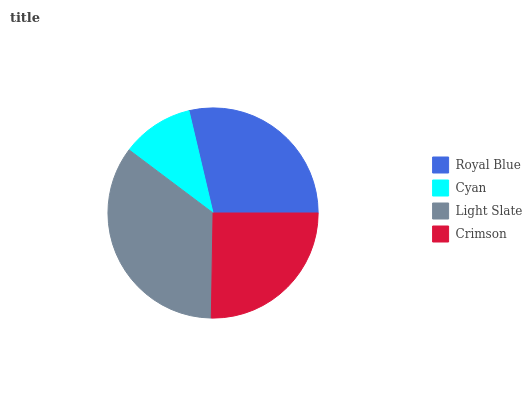Is Cyan the minimum?
Answer yes or no. Yes. Is Light Slate the maximum?
Answer yes or no. Yes. Is Light Slate the minimum?
Answer yes or no. No. Is Cyan the maximum?
Answer yes or no. No. Is Light Slate greater than Cyan?
Answer yes or no. Yes. Is Cyan less than Light Slate?
Answer yes or no. Yes. Is Cyan greater than Light Slate?
Answer yes or no. No. Is Light Slate less than Cyan?
Answer yes or no. No. Is Royal Blue the high median?
Answer yes or no. Yes. Is Crimson the low median?
Answer yes or no. Yes. Is Cyan the high median?
Answer yes or no. No. Is Royal Blue the low median?
Answer yes or no. No. 